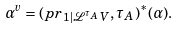Convert formula to latex. <formula><loc_0><loc_0><loc_500><loc_500>\alpha ^ { v } = ( p r _ { 1 | { \mathcal { L } } ^ { \tau _ { A } } V } , \tau _ { A } ) ^ { * } ( \alpha ) .</formula> 